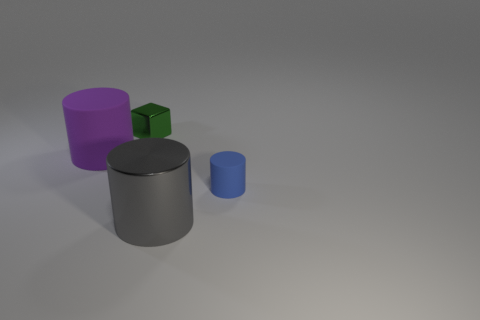Subtract all purple cylinders. How many cylinders are left? 2 Add 4 large gray matte cubes. How many objects exist? 8 Subtract all green cylinders. Subtract all blue spheres. How many cylinders are left? 3 Subtract all cubes. How many objects are left? 3 Subtract all large metallic things. Subtract all tiny blocks. How many objects are left? 2 Add 2 small blue rubber cylinders. How many small blue rubber cylinders are left? 3 Add 2 tiny blue cylinders. How many tiny blue cylinders exist? 3 Subtract 0 blue blocks. How many objects are left? 4 